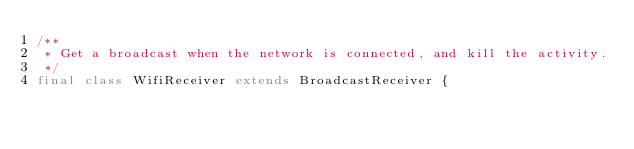<code> <loc_0><loc_0><loc_500><loc_500><_Java_>/**
 * Get a broadcast when the network is connected, and kill the activity.
 */
final class WifiReceiver extends BroadcastReceiver {
</code> 